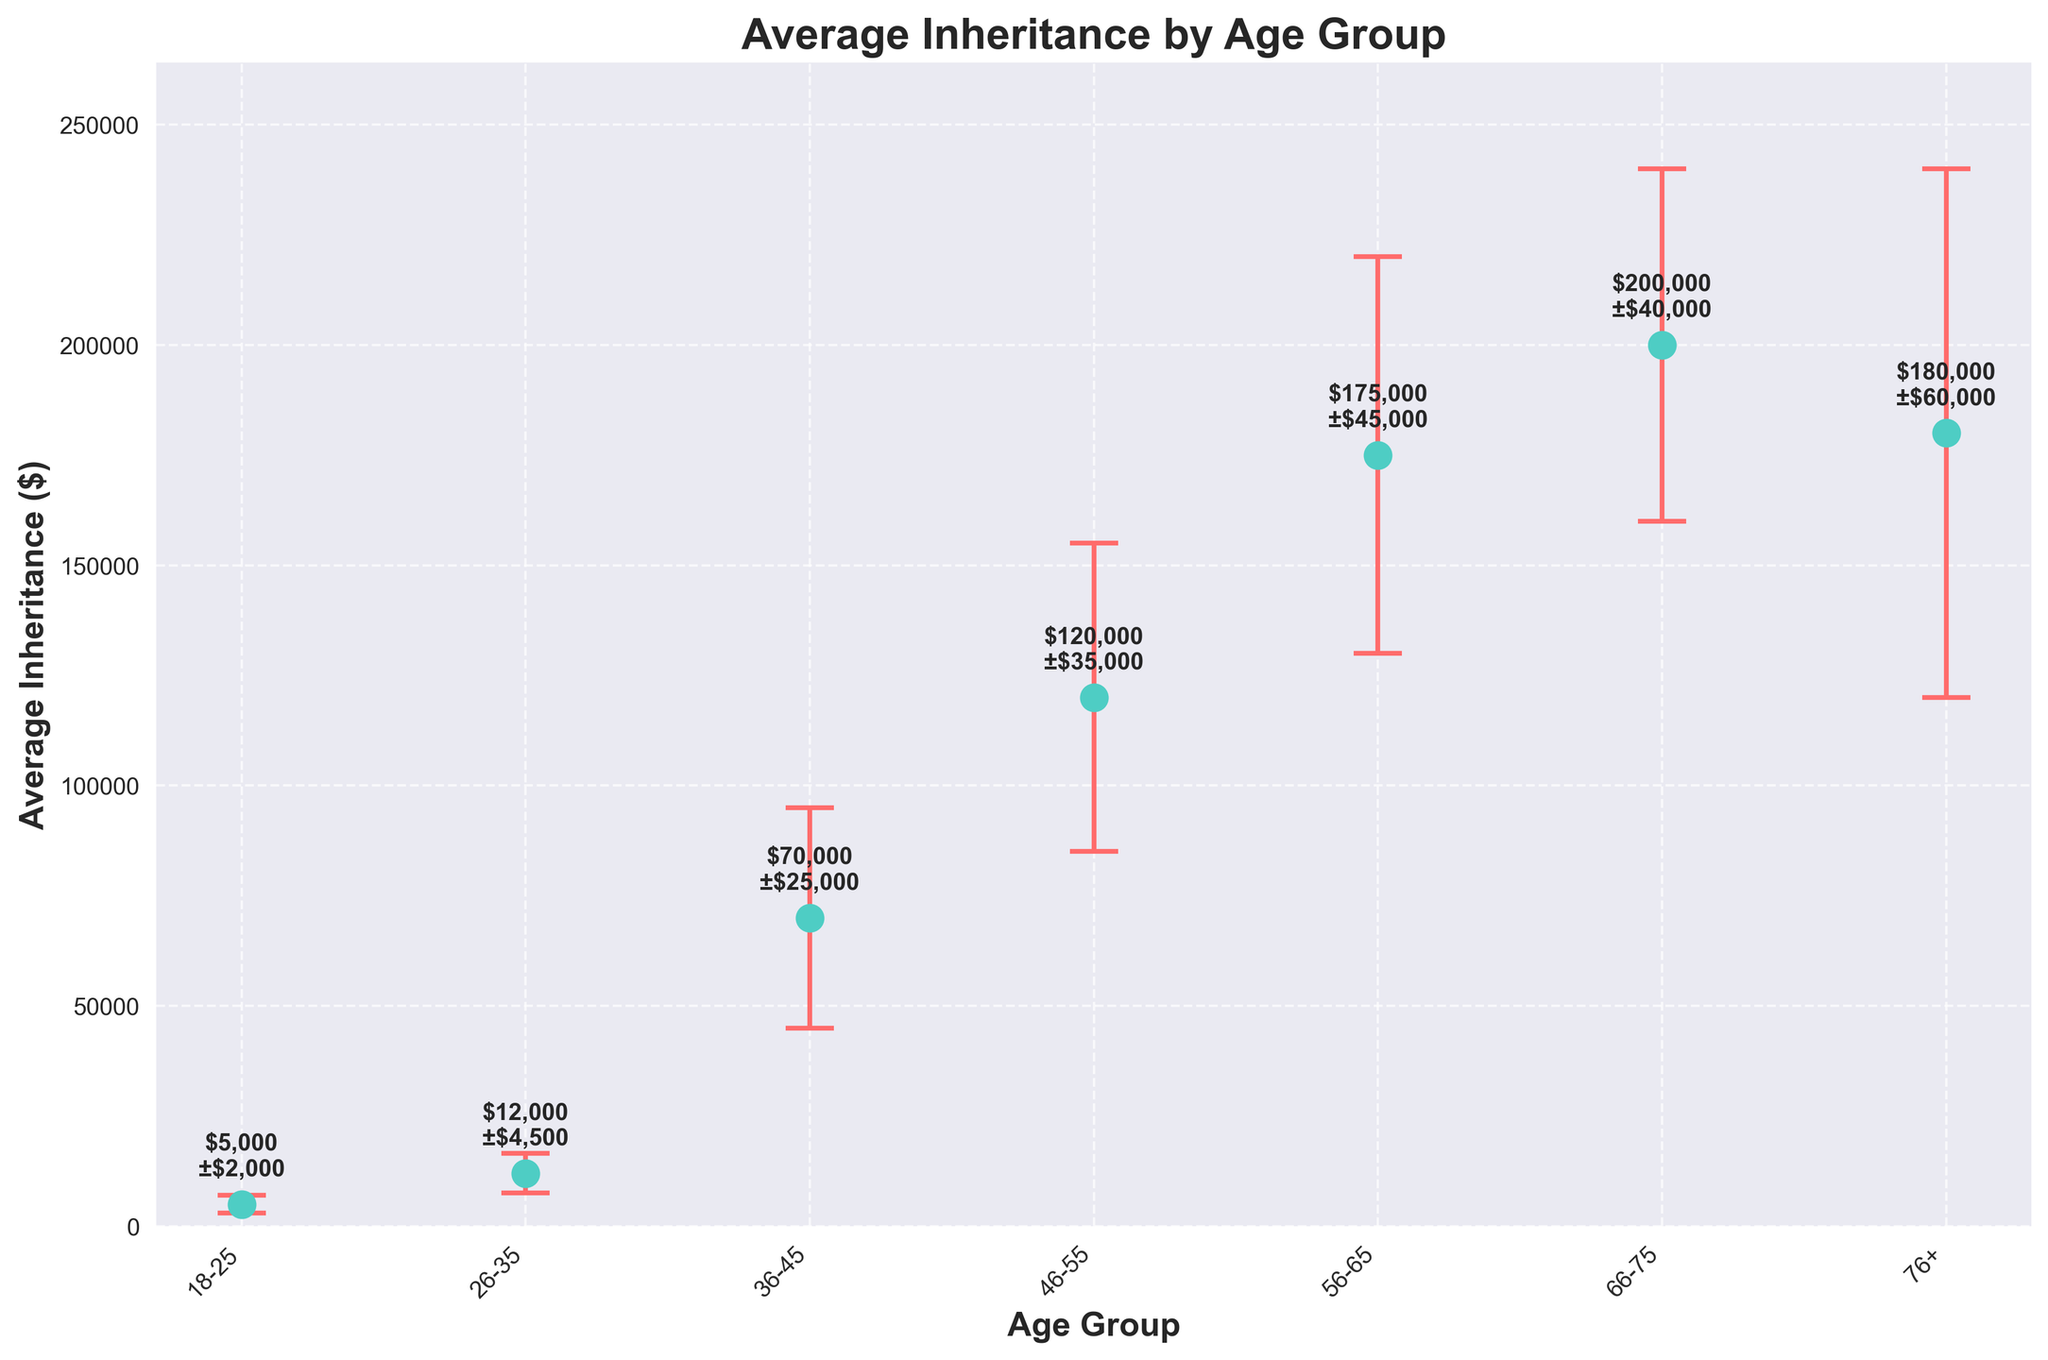What's the average inheritance for the 46-55 age group? To find the average inheritance for the 46-55 age group, simply locate the corresponding marker on the plot and read the average value.
Answer: $120,000 Which age group has the largest standard deviation in inheritance amounts? Locate the error bars on the plot and identify which is the longest since the longer the error bar, the larger the standard deviation. The 76+ age group has the largest error bar.
Answer: 76+ Compare the average inheritance of the 36-45 and 56-65 age groups. Which is higher and by how much? Identify the average inheritance values for both age groups from the markers on the plot. Subtract the average inheritance of the 36-45 age group from the 56-65 age group.
Answer: $105,000 higher What is the total average inheritance for all age groups combined? Sum the average inheritance amounts for all age groups displayed on the plot (5000 + 12000 + 70000 + 120000 + 175000 + 200000 + 180000)
Answer: $762,000 Are there any age groups where the average inheritance amount is within the range of another age group's standard deviation? For each age group, consider the average value plus/minus the standard deviation and compare these ranges with the average values of other age groups. Note any overlaps. The 26-35 age group's range (12000 ± 4500) overlaps with the 18-25 age group.
Answer: Yes, the 18-25 group overlaps with the 26-35 group What is the average inheritance difference between the youngest (18-25) and the oldest (76+) age groups? Find the average inheritance for both age groups and subtract the value of the youngest group from the oldest group (180000 - 5000).
Answer: $175,000 Which age group has the smallest average inheritance and what is the value? Identify the smallest marker on the plot, which is located in the 18-25 age group.
Answer: $5,000 What is the range of average inheritances for the middle-aged group (36-55)? Determine the average inheritance values for the 36-45 and 46-55 age groups, then subtract the smaller value (36-45, $70,000) from the larger value (46-55, $120,000).
Answer: $50,000 How many age groups have an average inheritance above $100,000? Count the number of data points (markers) on the plot that are positioned above the $100,000 mark. There are four such groups: 46-55, 56-65, 66-75, and 76+.
Answer: Four 